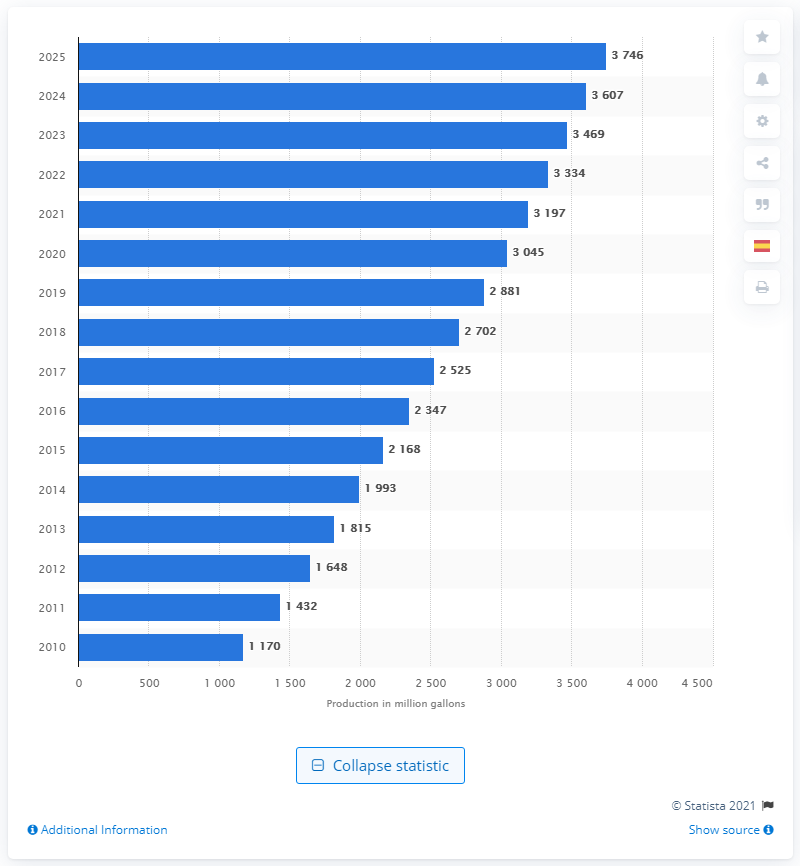List a handful of essential elements in this visual. Based on current projections, it is expected that the production of ethanol in the European Union will reach 3,746 million liters by 2025. 